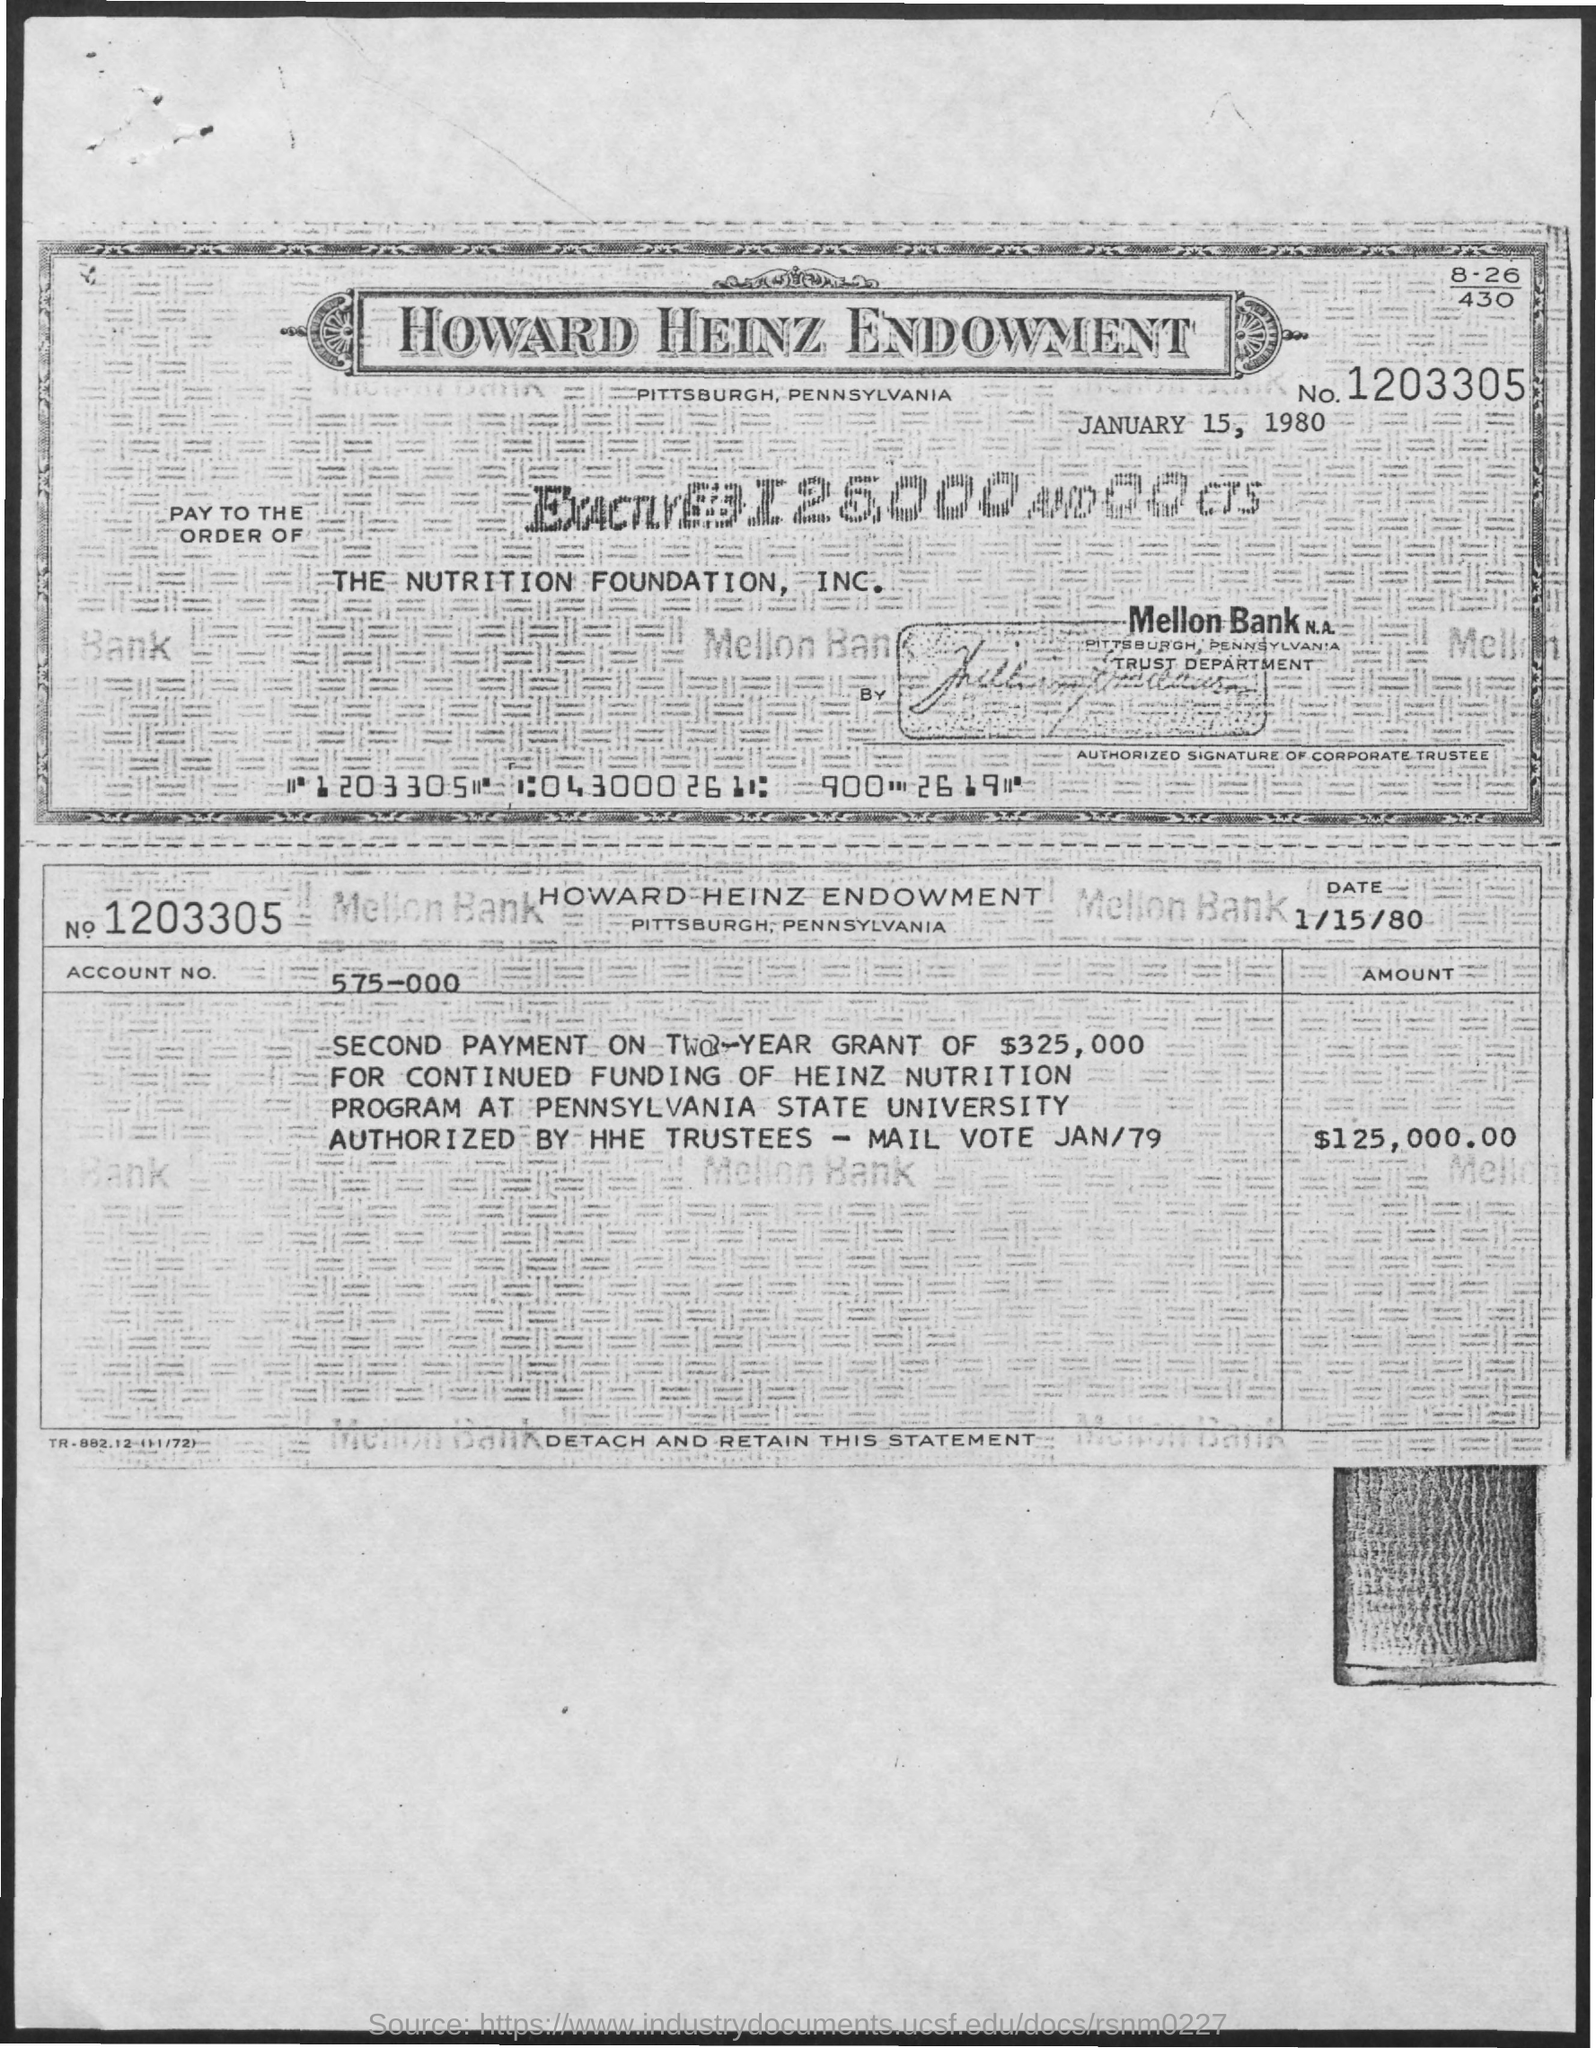What is the check no given?
Make the answer very short. 1203305. What is the amount of check?
Give a very brief answer. $125,000.00. What is the Account No. mentioned in the check?
Your response must be concise. 575-000. What is the check dated?
Give a very brief answer. JANUARY 15, 1980. In which company name, the check is issued?
Your answer should be compact. THE NUTRITION FOUNDATION, INC. 